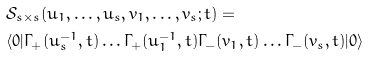<formula> <loc_0><loc_0><loc_500><loc_500>& \mathcal { S } _ { s \times s } ( u _ { 1 } , \dots , u _ { s } , v _ { 1 } , \dots , v _ { s } ; t ) = \\ & \langle 0 | \Gamma _ { + } ( u _ { s } ^ { - 1 } , t ) \dots \Gamma _ { + } ( u _ { 1 } ^ { - 1 } , t ) \Gamma _ { - } ( v _ { 1 } , t ) \dots \Gamma _ { - } ( v _ { s } , t ) | 0 \rangle</formula> 